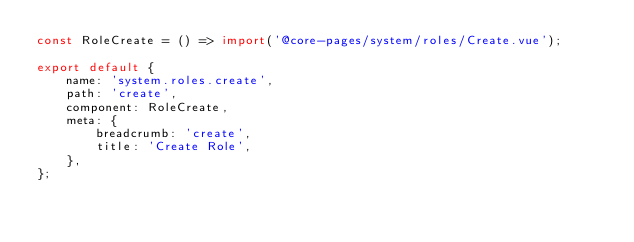Convert code to text. <code><loc_0><loc_0><loc_500><loc_500><_JavaScript_>const RoleCreate = () => import('@core-pages/system/roles/Create.vue');

export default {
    name: 'system.roles.create',
    path: 'create',
    component: RoleCreate,
    meta: {
        breadcrumb: 'create',
        title: 'Create Role',
    },
};
</code> 